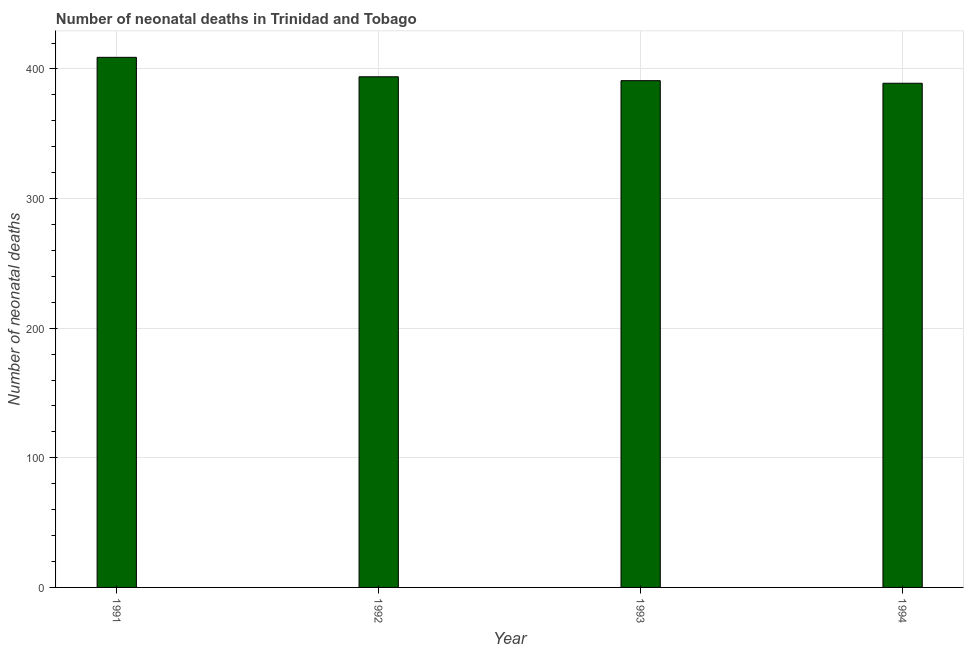Does the graph contain any zero values?
Give a very brief answer. No. What is the title of the graph?
Your response must be concise. Number of neonatal deaths in Trinidad and Tobago. What is the label or title of the X-axis?
Offer a terse response. Year. What is the label or title of the Y-axis?
Make the answer very short. Number of neonatal deaths. What is the number of neonatal deaths in 1991?
Ensure brevity in your answer.  409. Across all years, what is the maximum number of neonatal deaths?
Make the answer very short. 409. Across all years, what is the minimum number of neonatal deaths?
Make the answer very short. 389. In which year was the number of neonatal deaths minimum?
Offer a terse response. 1994. What is the sum of the number of neonatal deaths?
Keep it short and to the point. 1583. What is the average number of neonatal deaths per year?
Provide a succinct answer. 395. What is the median number of neonatal deaths?
Ensure brevity in your answer.  392.5. Do a majority of the years between 1991 and 1993 (inclusive) have number of neonatal deaths greater than 200 ?
Provide a succinct answer. Yes. Is the number of neonatal deaths in 1991 less than that in 1993?
Keep it short and to the point. No. Is the difference between the number of neonatal deaths in 1992 and 1993 greater than the difference between any two years?
Your answer should be very brief. No. What is the difference between the highest and the lowest number of neonatal deaths?
Your answer should be very brief. 20. In how many years, is the number of neonatal deaths greater than the average number of neonatal deaths taken over all years?
Give a very brief answer. 1. How many bars are there?
Keep it short and to the point. 4. Are all the bars in the graph horizontal?
Make the answer very short. No. How many years are there in the graph?
Offer a terse response. 4. What is the difference between two consecutive major ticks on the Y-axis?
Offer a terse response. 100. Are the values on the major ticks of Y-axis written in scientific E-notation?
Offer a very short reply. No. What is the Number of neonatal deaths in 1991?
Your answer should be compact. 409. What is the Number of neonatal deaths of 1992?
Keep it short and to the point. 394. What is the Number of neonatal deaths in 1993?
Give a very brief answer. 391. What is the Number of neonatal deaths in 1994?
Provide a succinct answer. 389. What is the difference between the Number of neonatal deaths in 1991 and 1992?
Give a very brief answer. 15. What is the difference between the Number of neonatal deaths in 1991 and 1993?
Provide a short and direct response. 18. What is the difference between the Number of neonatal deaths in 1991 and 1994?
Your answer should be very brief. 20. What is the difference between the Number of neonatal deaths in 1992 and 1993?
Your answer should be very brief. 3. What is the difference between the Number of neonatal deaths in 1993 and 1994?
Provide a short and direct response. 2. What is the ratio of the Number of neonatal deaths in 1991 to that in 1992?
Your answer should be very brief. 1.04. What is the ratio of the Number of neonatal deaths in 1991 to that in 1993?
Provide a succinct answer. 1.05. What is the ratio of the Number of neonatal deaths in 1991 to that in 1994?
Offer a terse response. 1.05. What is the ratio of the Number of neonatal deaths in 1992 to that in 1993?
Ensure brevity in your answer.  1.01. What is the ratio of the Number of neonatal deaths in 1993 to that in 1994?
Make the answer very short. 1. 